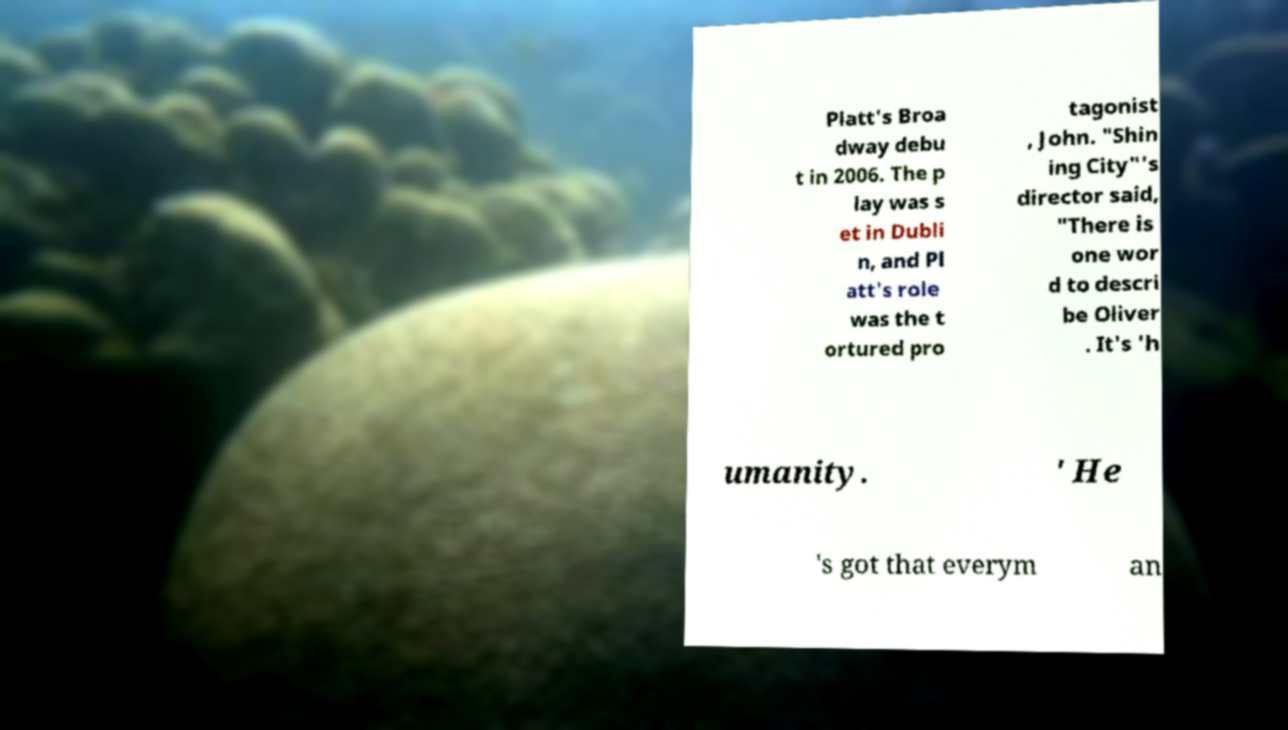Could you assist in decoding the text presented in this image and type it out clearly? Platt's Broa dway debu t in 2006. The p lay was s et in Dubli n, and Pl att's role was the t ortured pro tagonist , John. "Shin ing City"'s director said, "There is one wor d to descri be Oliver . It's 'h umanity. ' He 's got that everym an 